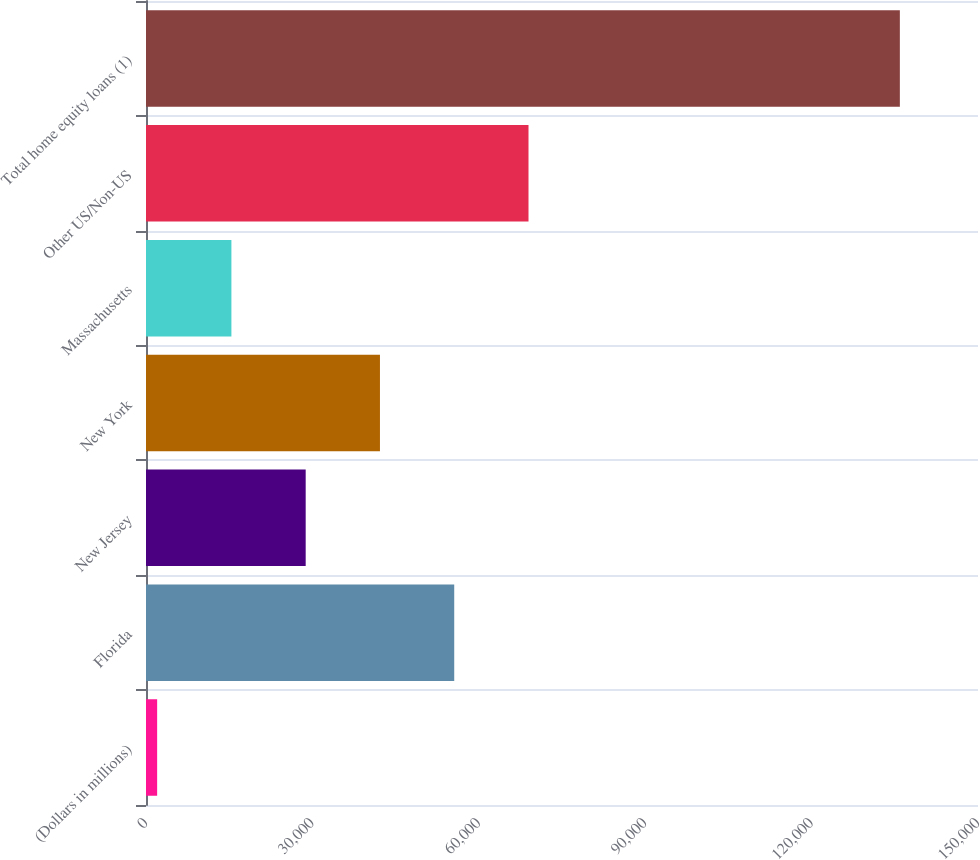<chart> <loc_0><loc_0><loc_500><loc_500><bar_chart><fcel>(Dollars in millions)<fcel>Florida<fcel>New Jersey<fcel>New York<fcel>Massachusetts<fcel>Other US/Non-US<fcel>Total home equity loans (1)<nl><fcel>2009<fcel>55570.2<fcel>28789.6<fcel>42179.9<fcel>15399.3<fcel>68960.5<fcel>135912<nl></chart> 